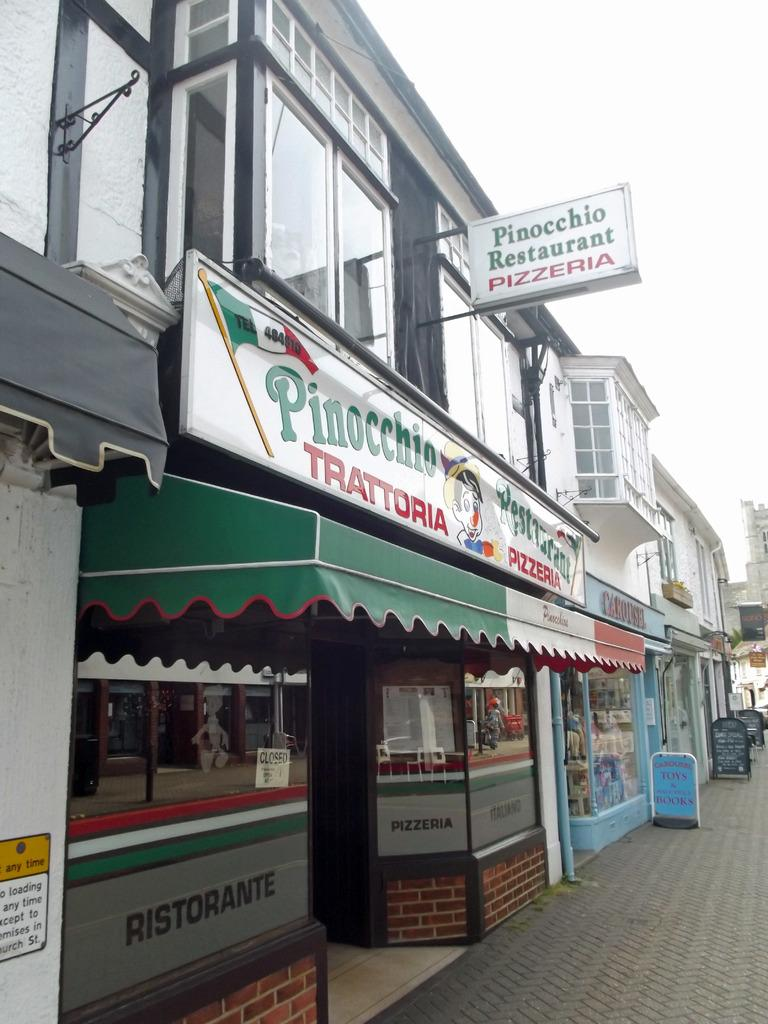<image>
Render a clear and concise summary of the photo. The storefront of the Pinocchio Pizzaria with a green, white and red awning. 